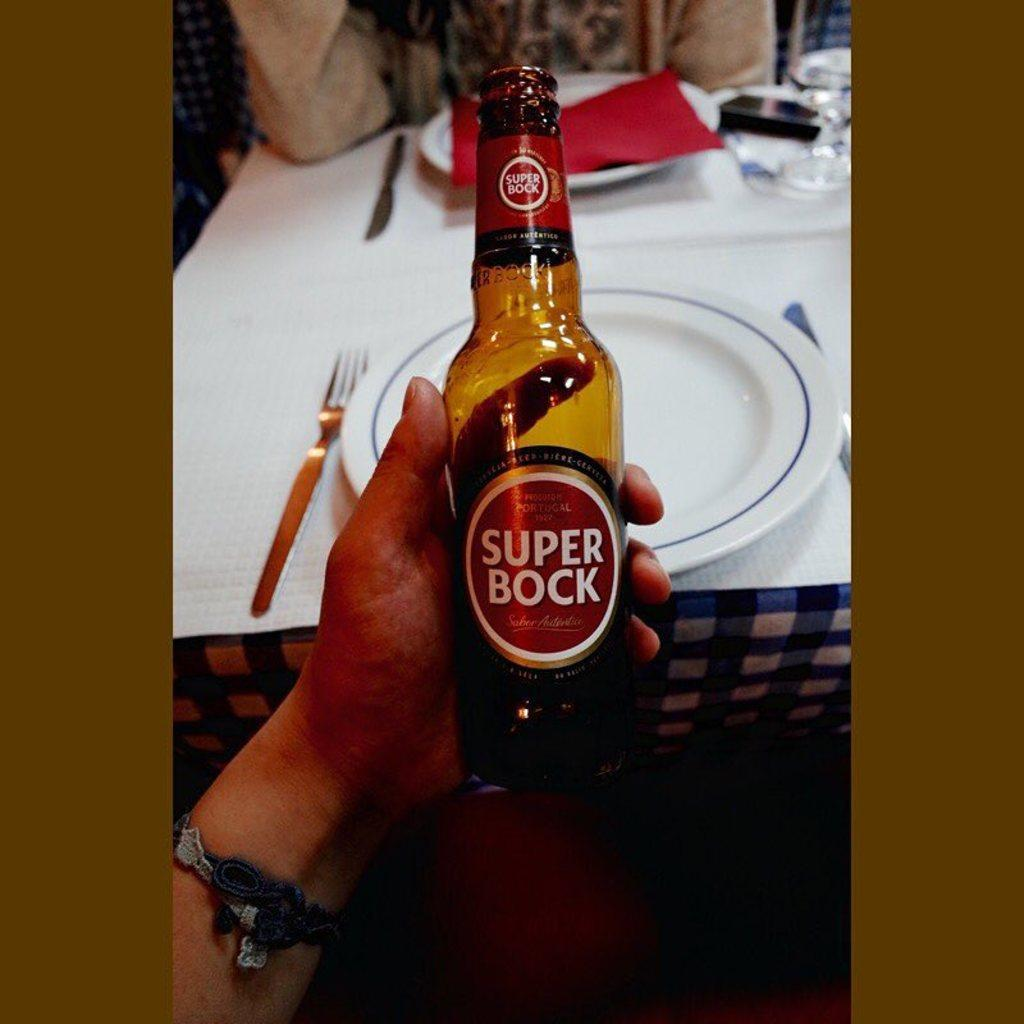What is the person holding in the image? The person is holding a bottle in the image. What else can be seen on the table besides the person and the bottle? There is a plate, a fork, a red cloth, a phone, and a glass on the table in the image. What might be used for eating in the image? The fork and the plate in the image might be used for eating. What object in the image is typically used for communication? The phone in the image is typically used for communication. What type of lettuce is being served on the plate in the image? There is no lettuce present on the plate in the image. What can be written in the notebook that is not visible in the image? There is no notebook present in the image. 